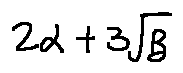<formula> <loc_0><loc_0><loc_500><loc_500>2 \alpha + 3 \sqrt { \beta }</formula> 